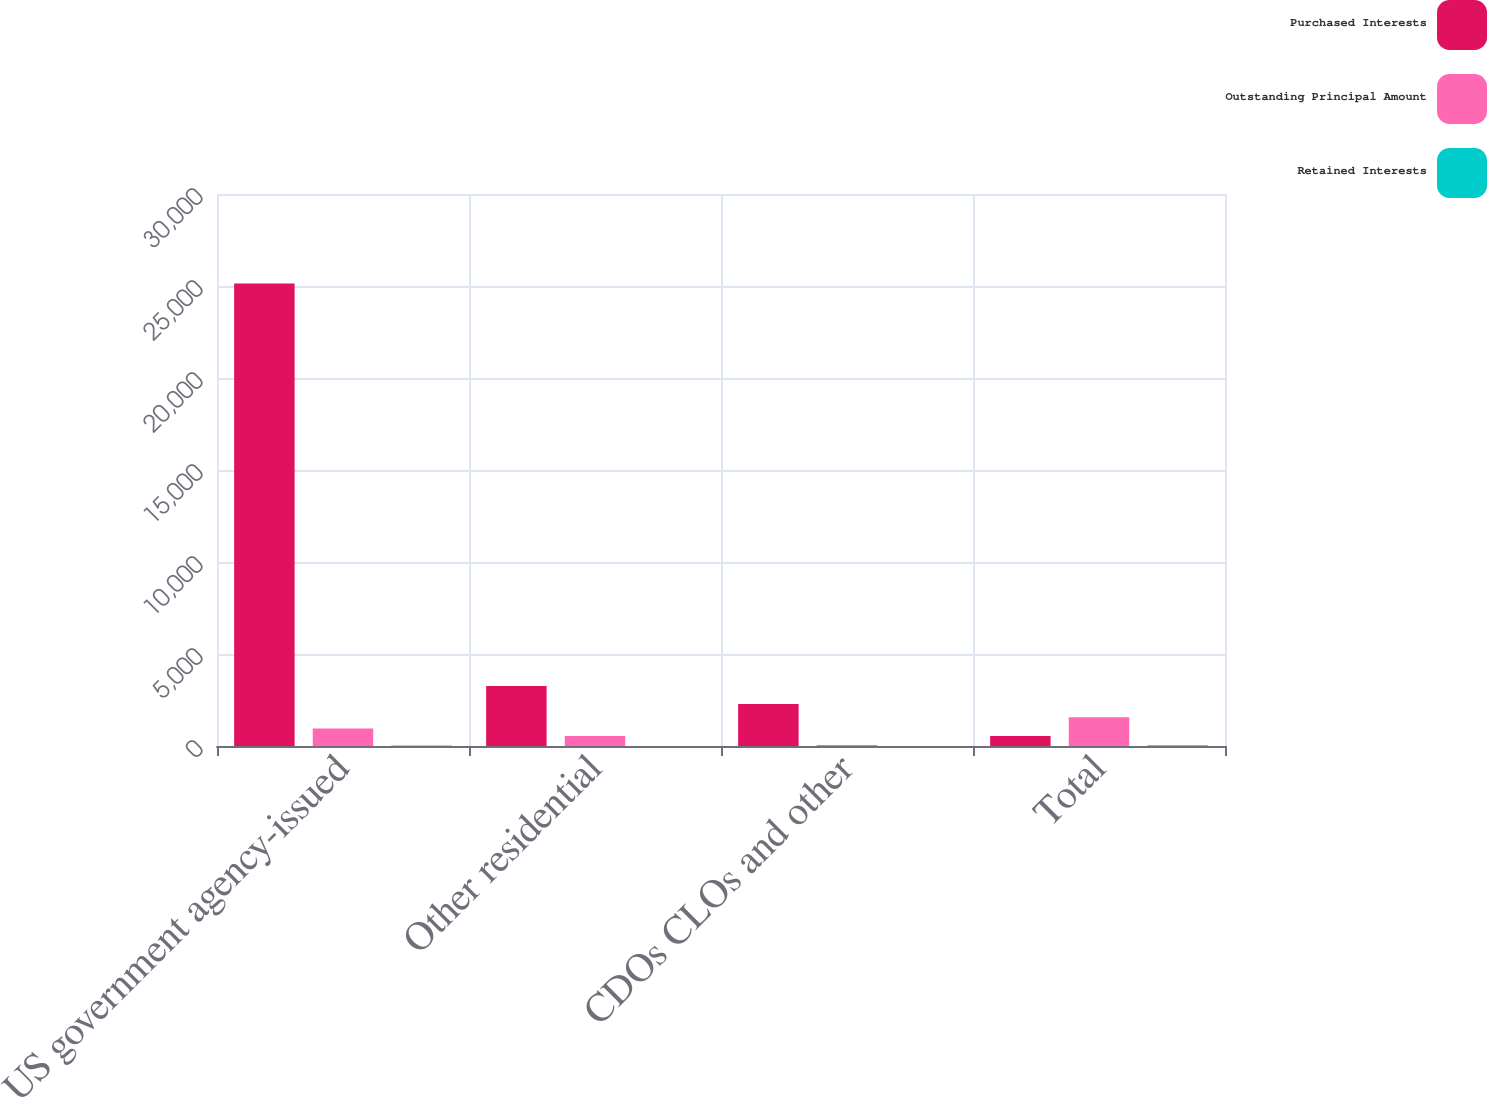<chart> <loc_0><loc_0><loc_500><loc_500><stacked_bar_chart><ecel><fcel>US government agency-issued<fcel>Other residential<fcel>CDOs CLOs and other<fcel>Total<nl><fcel>Purchased Interests<fcel>25140<fcel>3261<fcel>2284<fcel>540<nl><fcel>Outstanding Principal Amount<fcel>953<fcel>540<fcel>56<fcel>1564<nl><fcel>Retained Interests<fcel>24<fcel>6<fcel>6<fcel>36<nl></chart> 